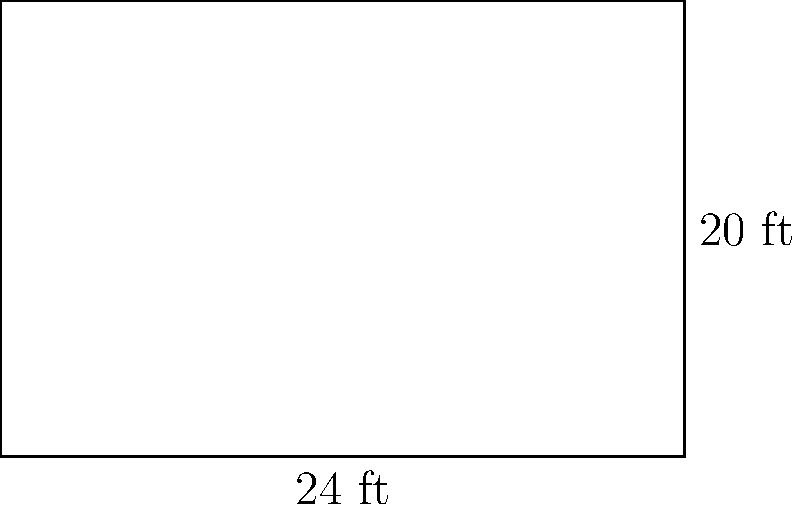As a sports journalist covering mixed martial arts, you're tasked with describing the dimensions of a standard UFC Octagon. However, you notice that for a special event, they're using a rectangular boxing ring instead. If the ring measures 24 feet in length and 20 feet in width, what is the perimeter of this boxing ring? To find the perimeter of the rectangular boxing ring, we need to follow these steps:

1) Recall the formula for the perimeter of a rectangle:
   $P = 2l + 2w$
   where $P$ is the perimeter, $l$ is the length, and $w$ is the width.

2) We're given:
   Length ($l$) = 24 feet
   Width ($w$) = 20 feet

3) Let's substitute these values into our formula:
   $P = 2(24) + 2(20)$

4) Simplify:
   $P = 48 + 40$

5) Calculate the final result:
   $P = 88$

Therefore, the perimeter of the boxing ring is 88 feet.
Answer: 88 feet 